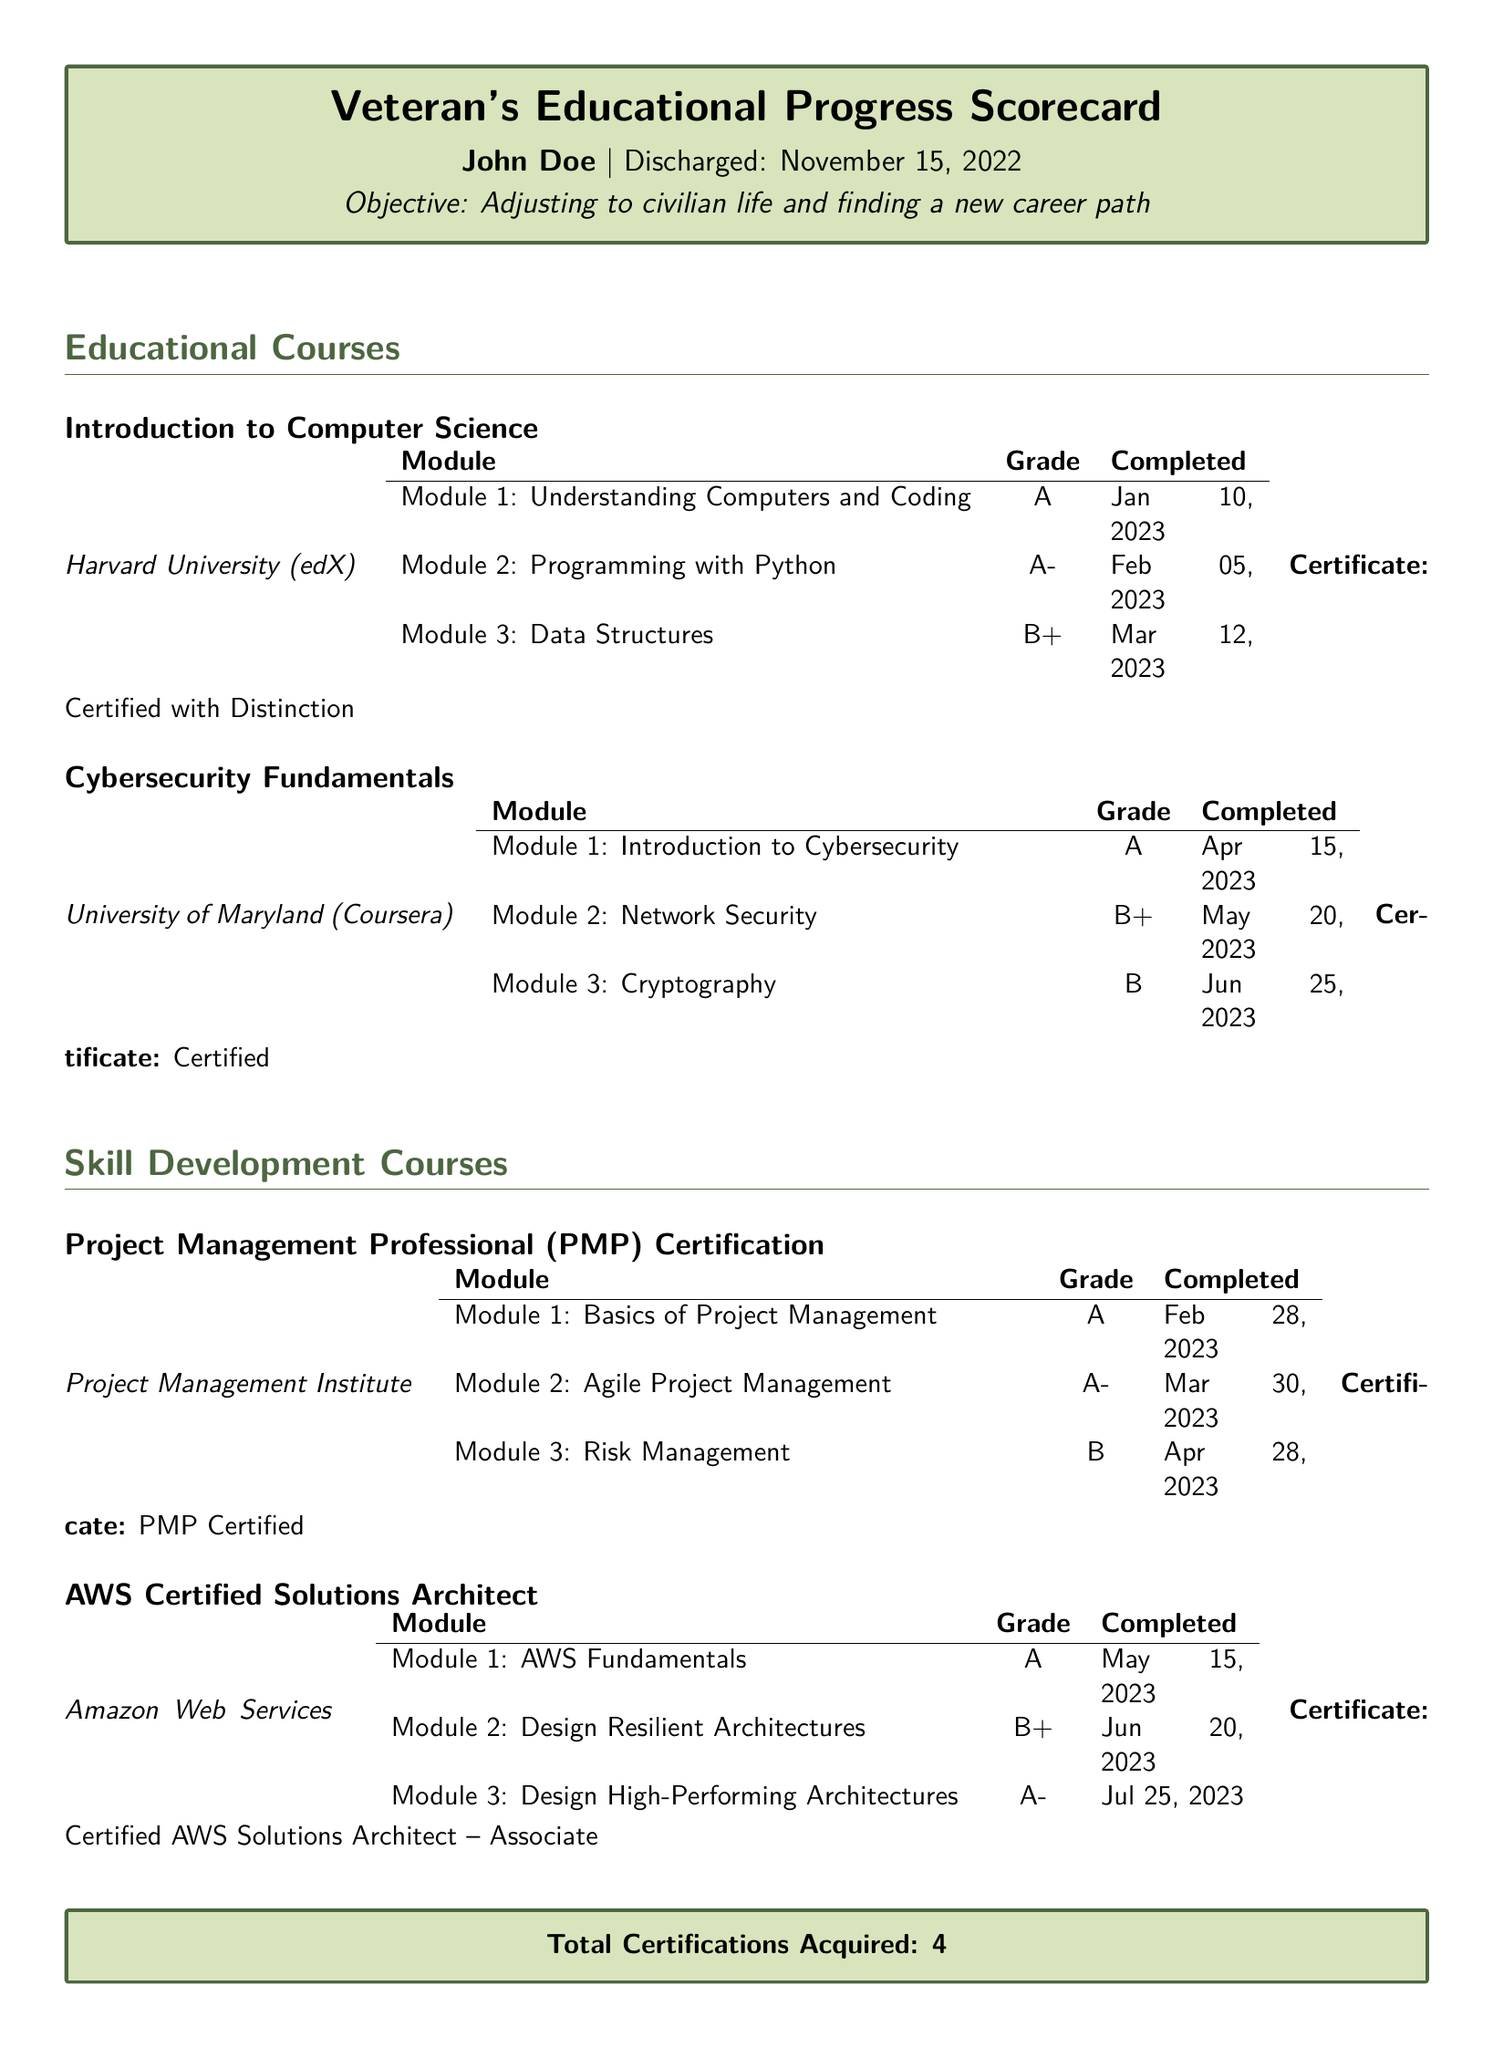What is the name of the first course completed? The first course listed in the document is "Introduction to Computer Science."
Answer: Introduction to Computer Science What grade was received in Module 2 of Cybersecurity Fundamentals? The grade for Module 2 of Cybersecurity Fundamentals is listed as B+.
Answer: B+ Who is the provider of the Project Management Professional Certification? The provider for the PMP Certification is the Project Management Institute.
Answer: Project Management Institute How many modules were completed in the AWS Certified Solutions Architect course? The document states there are three modules completed for the AWS Certified Solutions Architect course.
Answer: 3 What is the certification acquired for the Introduction to Computer Science course? The certification acquired for the Introduction to Computer Science course is noted as "Certified with Distinction."
Answer: Certified with Distinction What was the completion date for the last module of Cybersecurity Fundamentals? The completion date for the last module (Cryptography) is June 25, 2023.
Answer: June 25, 2023 What is the total number of certifications acquired? The total certifications section states that there are four certifications acquired.
Answer: 4 What grade was achieved in the last module of the AWS Certified Solutions Architect course? The grade for the last module (Design High-Performing Architectures) is A-.
Answer: A- Which course had the lowest grade in its modules? Among the courses, Cybersecurity Fundamentals had the lowest grade (B) in Module 3.
Answer: Cybersecurity Fundamentals 